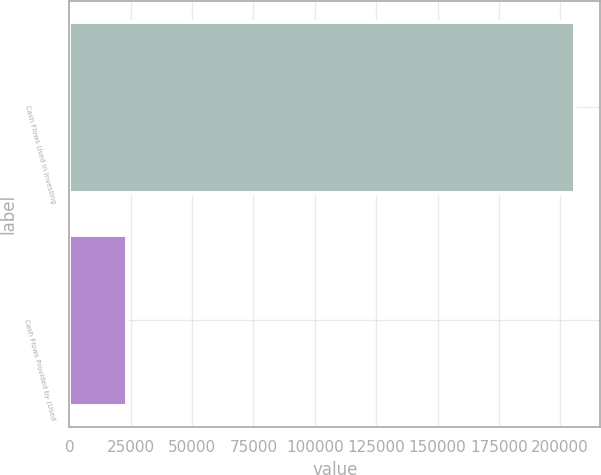<chart> <loc_0><loc_0><loc_500><loc_500><bar_chart><fcel>Cash Flows Used in Investing<fcel>Cash Flows Provided by (Used<nl><fcel>206087<fcel>23271<nl></chart> 